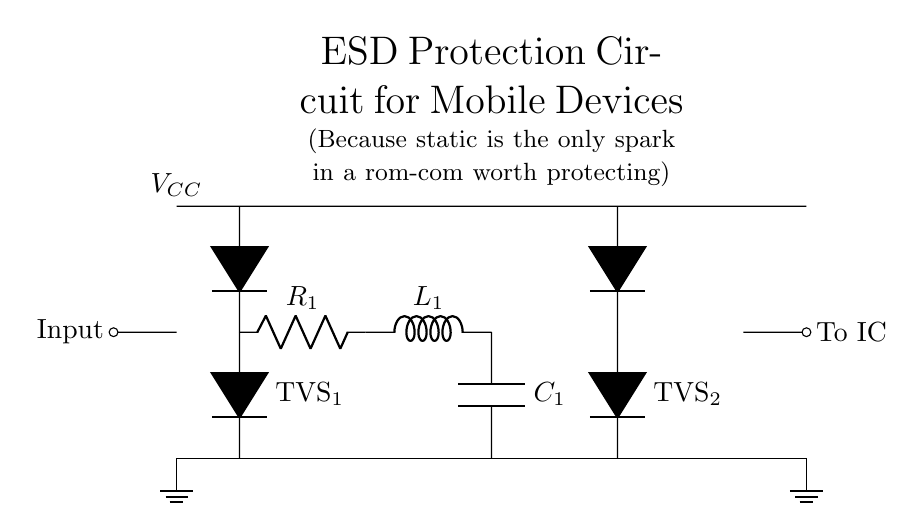What type of protection does this circuit provide? The circuit provides ESD protection, which is specifically designed to safeguard the components from electrostatic discharge that can damage sensitive electronic parts.
Answer: ESD protection What is the value of the series resistor in the circuit? The circuit shows a series resistor labeled as R1, but no specific numerical value is provided in the diagram itself, so it cannot be determined from the visual.
Answer: Not specified How many TVS diodes are present in this circuit? The circuit contains two TVS diodes labeled as TVS1 and TVS2, indicating multiple protection points for ESD.
Answer: Two What do L1 and C1 represent in the circuit? L1 represents an inductor and C1 represents a capacitor, which together form a low-pass LC filter intended to reduce noise and voltage spikes from entering the circuit.
Answer: Inductor and capacitor Why is the circuit grounded at both ends? Grounding at both ends ensures complete circuit stability and allows any excess static charge to flow safely to the ground, preventing damage to the mobile device components.
Answer: Stability and safety What is the significance of having two TVS diodes in the circuit? The presence of two TVS diodes allows for bidirectional protection from ESD, meaning the circuit can defend components from discharge events that occur in both directions, enhancing reliability.
Answer: Bidirectional protection From which point does the voltage supply enter the circuit? The voltage supply, denoted as VCC, enters at the top left corner of the circuit diagram, indicating the power source for the components.
Answer: Top left corner 